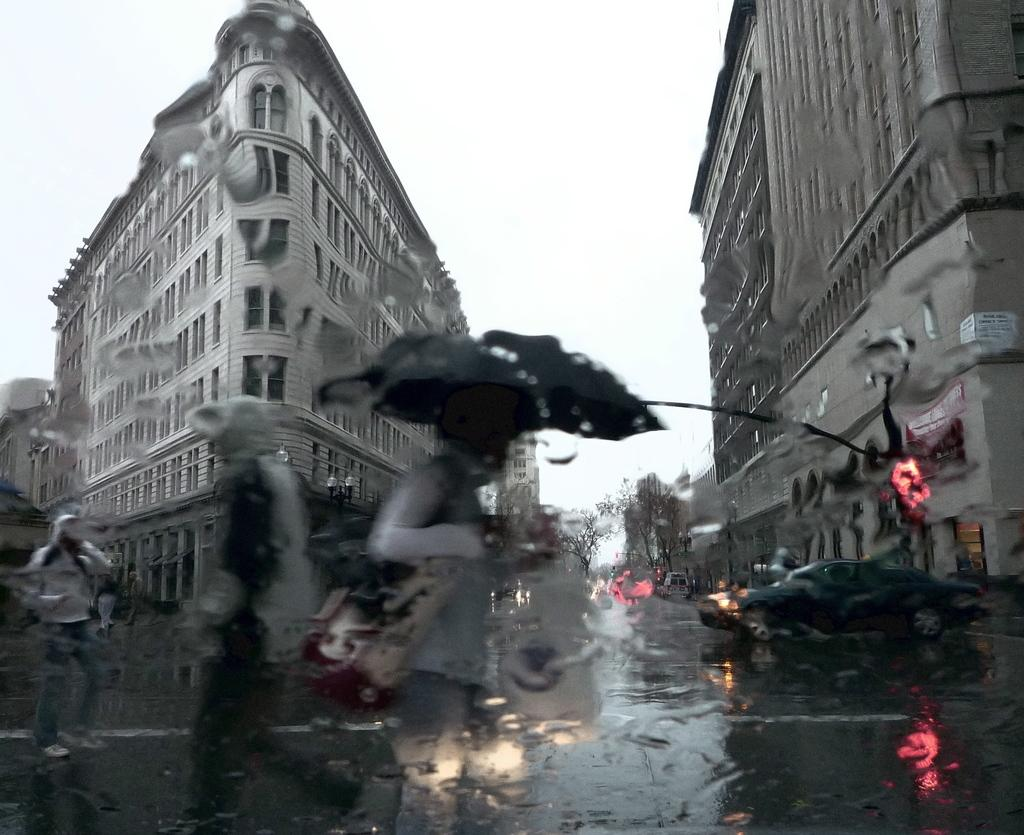What can be seen moving in the image? There are vehicles and people walking on the road in the image. What object is being used for protection from the elements? There is an umbrella in the image. What items might people be carrying with them? There are bags in the image. What type of vegetation is visible in the image? There are trees in the image. What type of structures can be seen in the image? There are buildings with windows in the image. What is visible in the background of the image? The sky is visible in the background of the image. What type of debt is being discussed by the people walking on the road in the image? There is no indication of any debt being discussed in the image; people are simply walking on the road. What type of thing is being used to measure the distance between the buildings in the image? There is no measuring device visible in the image, and the distance between the buildings is not being measured. 